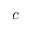<formula> <loc_0><loc_0><loc_500><loc_500>c</formula> 